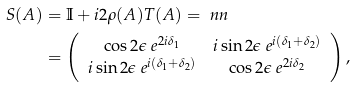Convert formula to latex. <formula><loc_0><loc_0><loc_500><loc_500>S ( A ) & = \mathbb { I } + i 2 \rho ( A ) T ( A ) = \ n n \\ & = \left ( \begin{array} { c c } \cos 2 \epsilon \ e ^ { 2 i \delta _ { 1 } } & i \sin 2 \epsilon \ e ^ { i ( \delta _ { 1 } + \delta _ { 2 } ) } \\ i \sin 2 \epsilon \ e ^ { i ( \delta _ { 1 } + \delta _ { 2 } ) } & \cos 2 \epsilon \ e ^ { 2 i \delta _ { 2 } } \end{array} \right ) \text {,}</formula> 